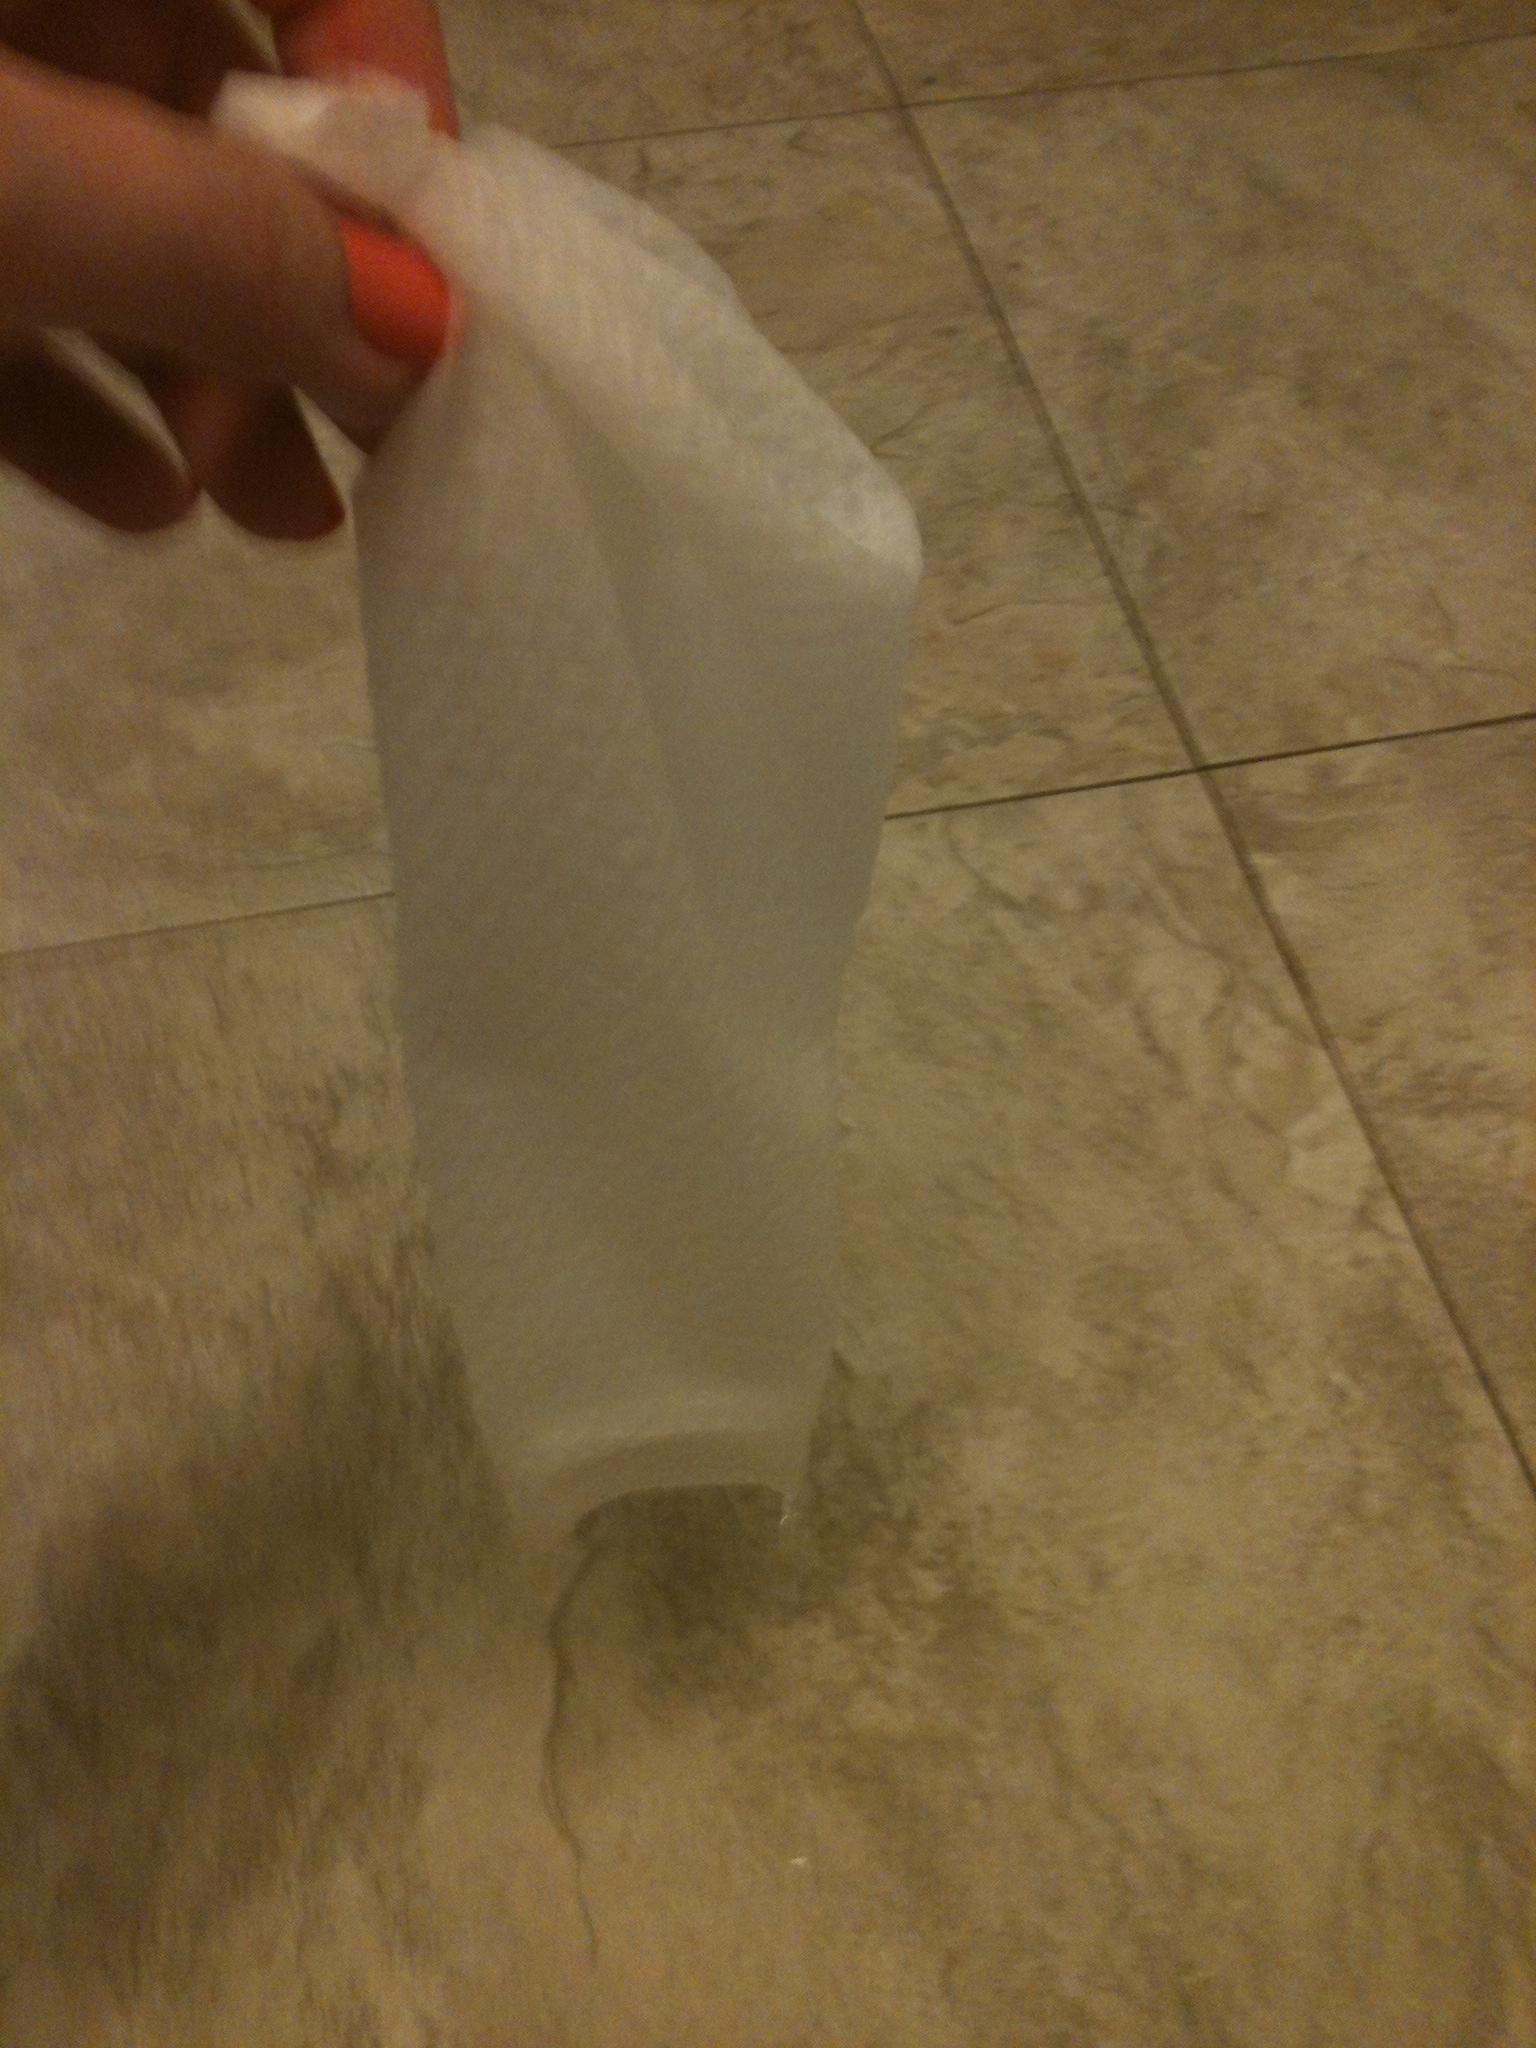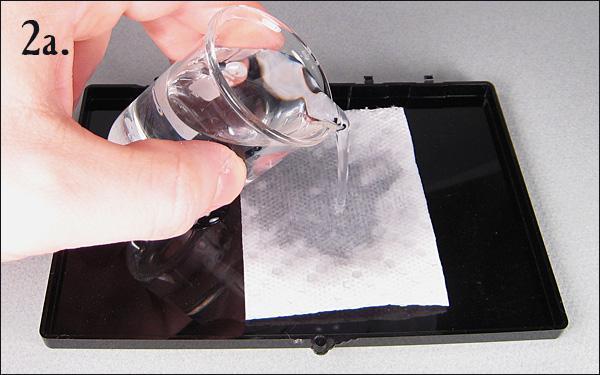The first image is the image on the left, the second image is the image on the right. For the images shown, is this caption "One image shows a paper towel dipped in at least one colored liquid, and the other image includes a glass of clear liquid and a paper towel." true? Answer yes or no. No. The first image is the image on the left, the second image is the image on the right. For the images displayed, is the sentence "A paper towel is soaking in liquid in at least to glasses." factually correct? Answer yes or no. No. 